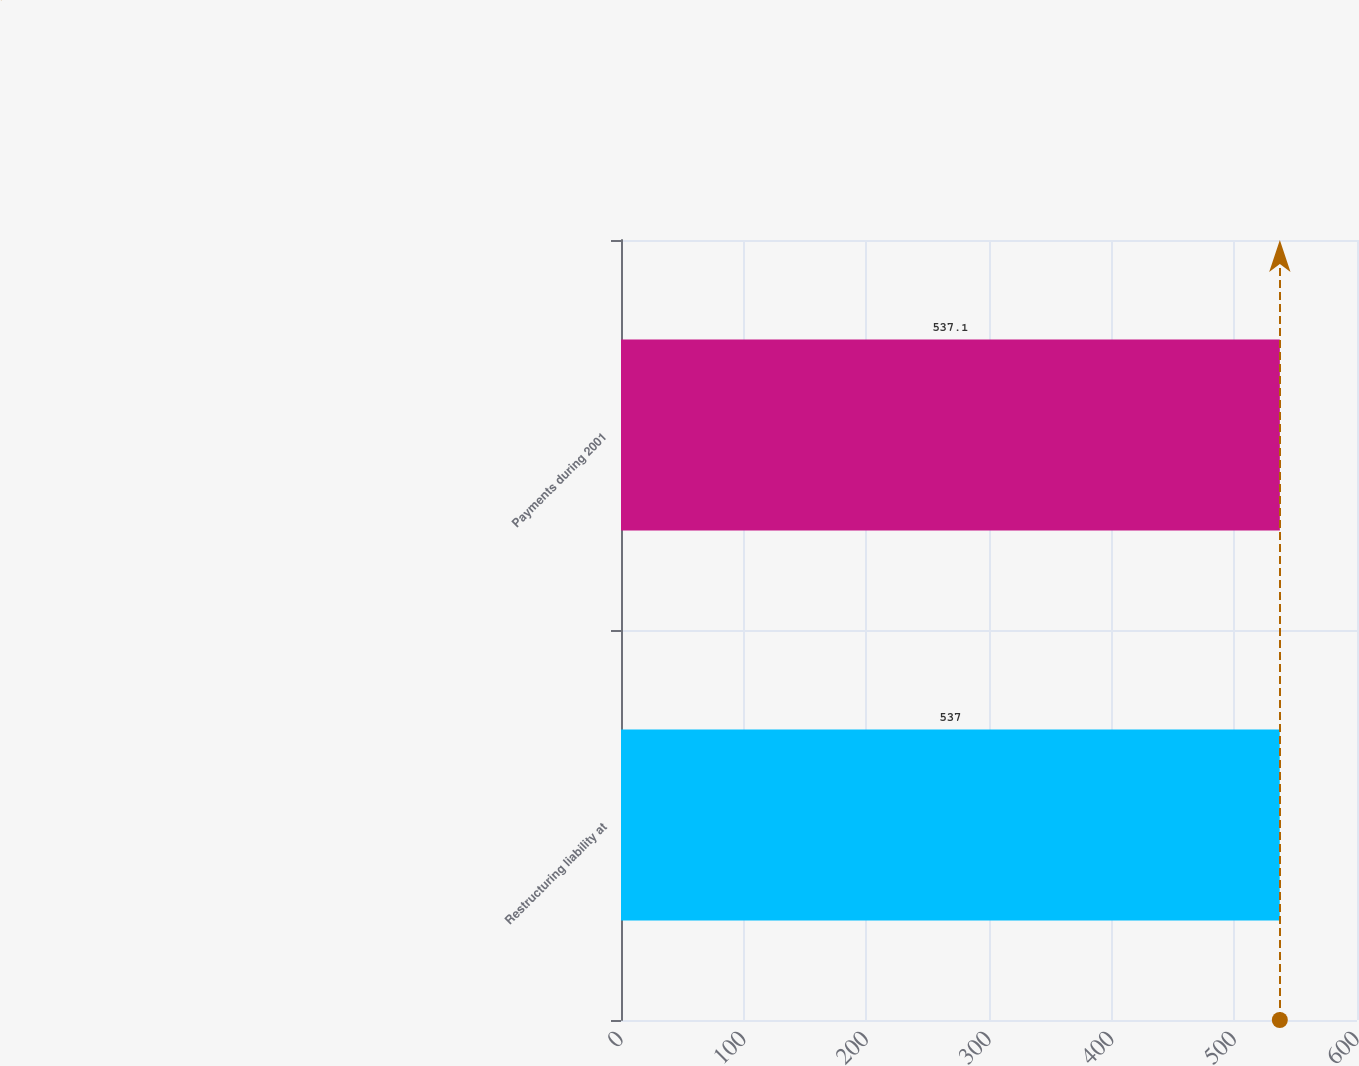Convert chart to OTSL. <chart><loc_0><loc_0><loc_500><loc_500><bar_chart><fcel>Restructuring liability at<fcel>Payments during 2001<nl><fcel>537<fcel>537.1<nl></chart> 